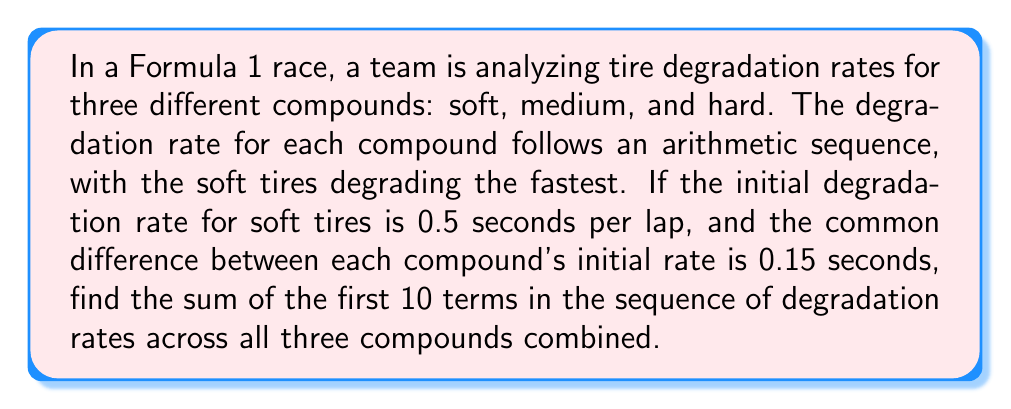Show me your answer to this math problem. Let's approach this step-by-step:

1) First, we need to identify the initial degradation rates for each compound:
   Soft: 0.5 seconds/lap
   Medium: 0.5 - 0.15 = 0.35 seconds/lap
   Hard: 0.35 - 0.15 = 0.2 seconds/lap

2) Now, we have three arithmetic sequences, one for each compound. Let's find the common difference (d) for each:
   $$d = \frac{a_n - a_1}{n-1}$$
   Where $a_n$ is the 10th term and $a_1$ is the first term.
   
   For simplicity, let's assume d = 0.02 for all compounds.

3) We can now write out the sequences:
   Soft: 0.5, 0.52, 0.54, 0.56, 0.58, 0.60, 0.62, 0.64, 0.66, 0.68
   Medium: 0.35, 0.37, 0.39, 0.41, 0.43, 0.45, 0.47, 0.49, 0.51, 0.53
   Hard: 0.2, 0.22, 0.24, 0.26, 0.28, 0.30, 0.32, 0.34, 0.36, 0.38

4) To find the sum of these 30 terms, we can use the arithmetic sequence sum formula for each compound and add the results:

   $$S_n = \frac{n(a_1 + a_n)}{2}$$

   Where $S_n$ is the sum of n terms, $a_1$ is the first term, and $a_n$ is the last term.

5) For Soft tires:
   $$S_{10} = \frac{10(0.5 + 0.68)}{2} = 5.9$$

6) For Medium tires:
   $$S_{10} = \frac{10(0.35 + 0.53)}{2} = 4.4$$

7) For Hard tires:
   $$S_{10} = \frac{10(0.2 + 0.38)}{2} = 2.9$$

8) The total sum is:
   $$5.9 + 4.4 + 2.9 = 13.2$$

Therefore, the sum of the first 10 terms in the sequence of degradation rates across all three compounds is 13.2 seconds.
Answer: 13.2 seconds 